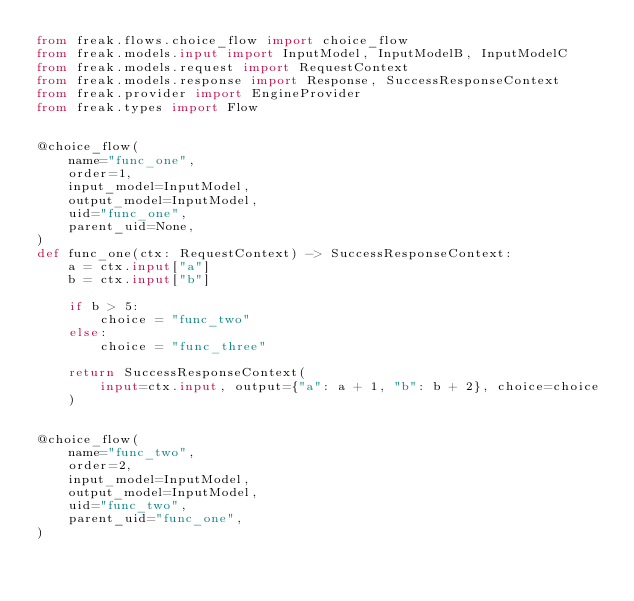Convert code to text. <code><loc_0><loc_0><loc_500><loc_500><_Python_>from freak.flows.choice_flow import choice_flow
from freak.models.input import InputModel, InputModelB, InputModelC
from freak.models.request import RequestContext
from freak.models.response import Response, SuccessResponseContext
from freak.provider import EngineProvider
from freak.types import Flow


@choice_flow(
    name="func_one",
    order=1,
    input_model=InputModel,
    output_model=InputModel,
    uid="func_one",
    parent_uid=None,
)
def func_one(ctx: RequestContext) -> SuccessResponseContext:
    a = ctx.input["a"]
    b = ctx.input["b"]

    if b > 5:
        choice = "func_two"
    else:
        choice = "func_three"

    return SuccessResponseContext(
        input=ctx.input, output={"a": a + 1, "b": b + 2}, choice=choice
    )


@choice_flow(
    name="func_two",
    order=2,
    input_model=InputModel,
    output_model=InputModel,
    uid="func_two",
    parent_uid="func_one",
)</code> 